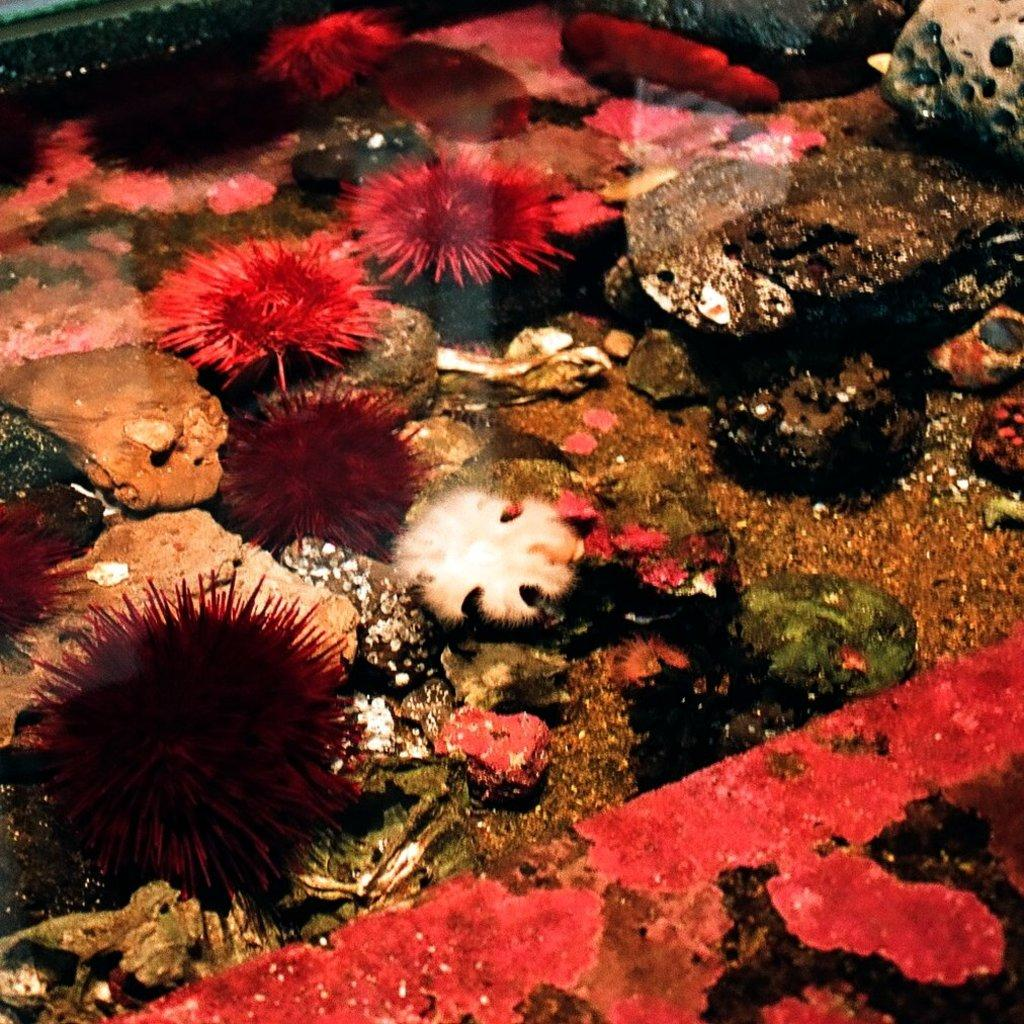What type of environment is depicted in the image? The image shows an underwater view of the sea. What geological features can be seen in the image? There are coral rocks visible in the image. Are there any plants or flowers visible in the image? Yes, there are pink-colored flowers in the image. What type of song is being sung by the fish in the image? There are no fish or any indication of singing in the image; it shows an underwater view of the sea with coral rocks and pink-colored flowers. 